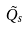Convert formula to latex. <formula><loc_0><loc_0><loc_500><loc_500>\tilde { Q _ { s } }</formula> 